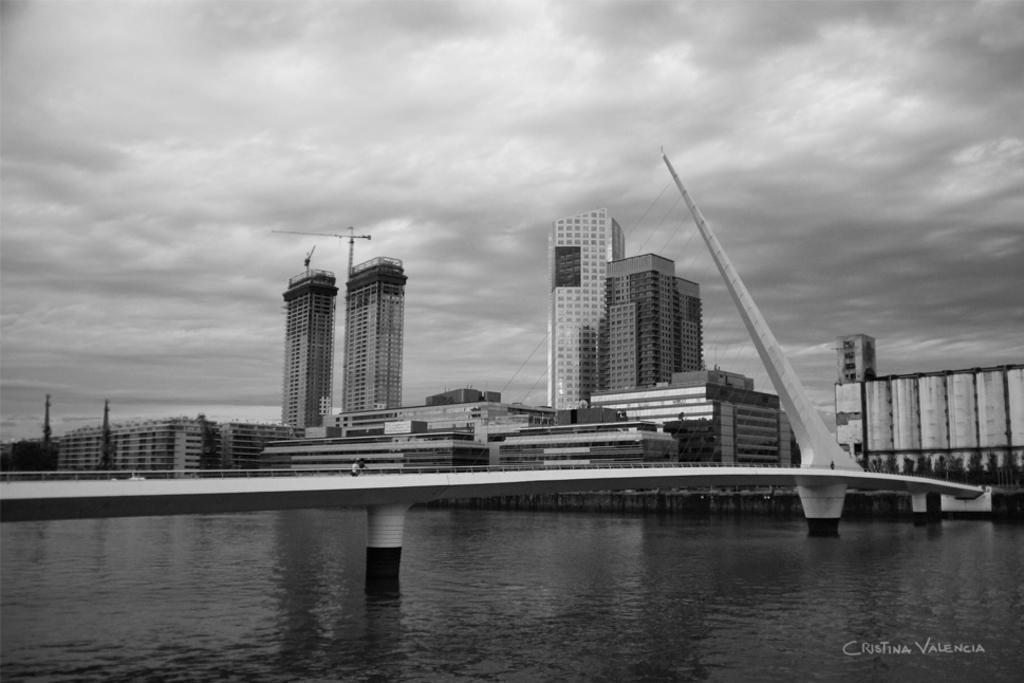Please provide a concise description of this image. In the foreground we can see bridgewater body, person, railing, cables and other objects. In the middle of the picture there are buildings. At the top it is sky, sky is cloudy. 